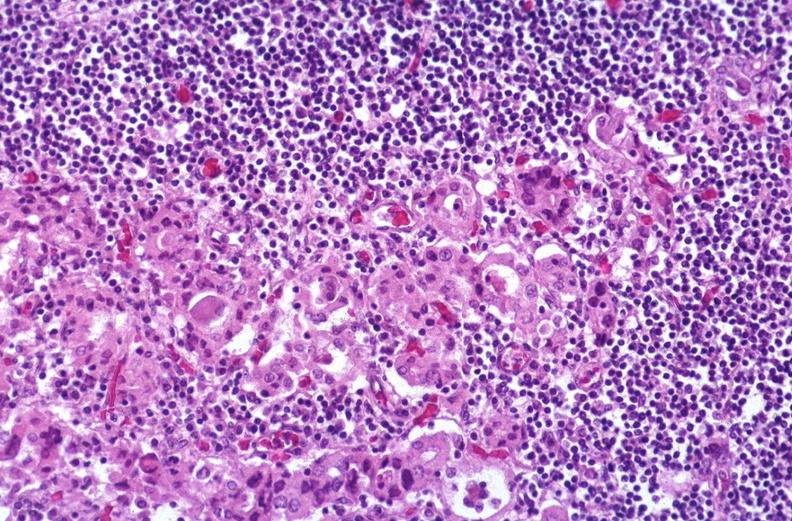s endocrine present?
Answer the question using a single word or phrase. Yes 